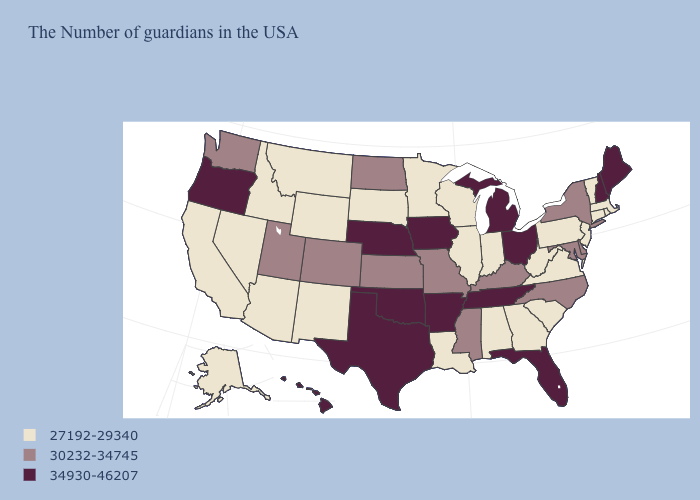Name the states that have a value in the range 27192-29340?
Write a very short answer. Massachusetts, Rhode Island, Vermont, Connecticut, New Jersey, Pennsylvania, Virginia, South Carolina, West Virginia, Georgia, Indiana, Alabama, Wisconsin, Illinois, Louisiana, Minnesota, South Dakota, Wyoming, New Mexico, Montana, Arizona, Idaho, Nevada, California, Alaska. What is the lowest value in the USA?
Write a very short answer. 27192-29340. What is the value of Florida?
Write a very short answer. 34930-46207. What is the value of New York?
Be succinct. 30232-34745. What is the value of Missouri?
Keep it brief. 30232-34745. Name the states that have a value in the range 27192-29340?
Give a very brief answer. Massachusetts, Rhode Island, Vermont, Connecticut, New Jersey, Pennsylvania, Virginia, South Carolina, West Virginia, Georgia, Indiana, Alabama, Wisconsin, Illinois, Louisiana, Minnesota, South Dakota, Wyoming, New Mexico, Montana, Arizona, Idaho, Nevada, California, Alaska. Does the first symbol in the legend represent the smallest category?
Concise answer only. Yes. Name the states that have a value in the range 27192-29340?
Answer briefly. Massachusetts, Rhode Island, Vermont, Connecticut, New Jersey, Pennsylvania, Virginia, South Carolina, West Virginia, Georgia, Indiana, Alabama, Wisconsin, Illinois, Louisiana, Minnesota, South Dakota, Wyoming, New Mexico, Montana, Arizona, Idaho, Nevada, California, Alaska. Does Colorado have a lower value than Illinois?
Short answer required. No. Name the states that have a value in the range 34930-46207?
Give a very brief answer. Maine, New Hampshire, Ohio, Florida, Michigan, Tennessee, Arkansas, Iowa, Nebraska, Oklahoma, Texas, Oregon, Hawaii. What is the value of Nevada?
Quick response, please. 27192-29340. Among the states that border North Dakota , which have the lowest value?
Keep it brief. Minnesota, South Dakota, Montana. Name the states that have a value in the range 27192-29340?
Quick response, please. Massachusetts, Rhode Island, Vermont, Connecticut, New Jersey, Pennsylvania, Virginia, South Carolina, West Virginia, Georgia, Indiana, Alabama, Wisconsin, Illinois, Louisiana, Minnesota, South Dakota, Wyoming, New Mexico, Montana, Arizona, Idaho, Nevada, California, Alaska. Does the map have missing data?
Quick response, please. No. Does the first symbol in the legend represent the smallest category?
Concise answer only. Yes. 